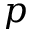<formula> <loc_0><loc_0><loc_500><loc_500>p</formula> 